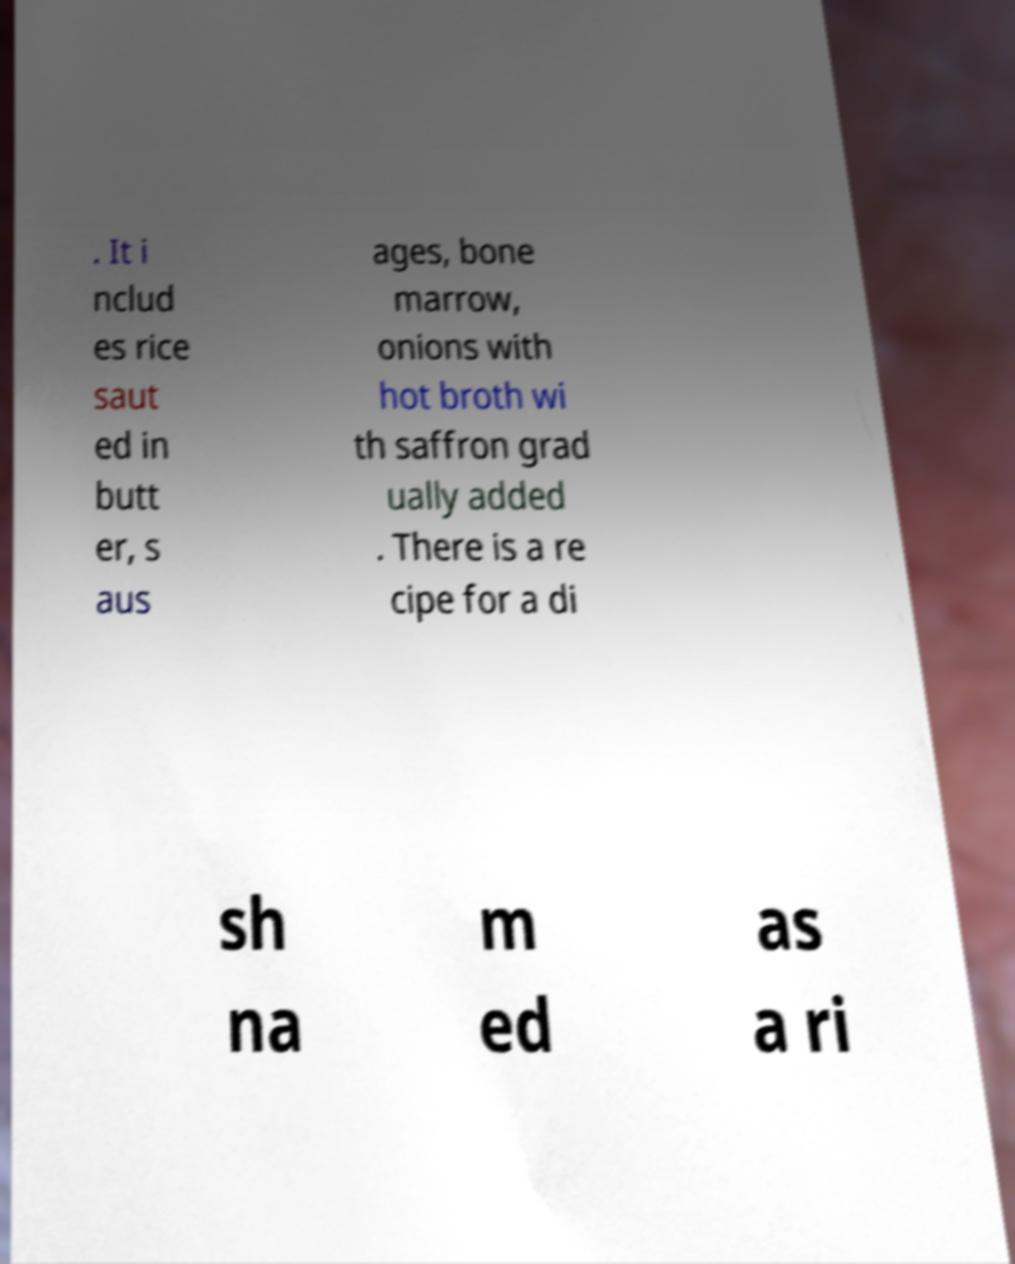Could you assist in decoding the text presented in this image and type it out clearly? . It i nclud es rice saut ed in butt er, s aus ages, bone marrow, onions with hot broth wi th saffron grad ually added . There is a re cipe for a di sh na m ed as a ri 